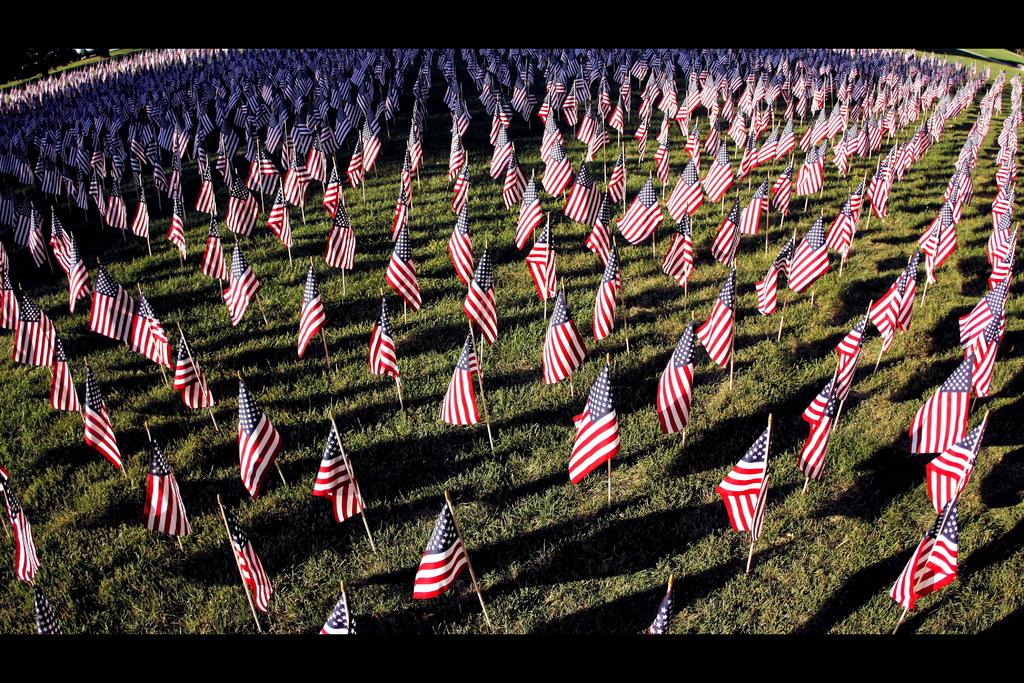What type of flags are visible in the image? There are US flags in the image. Where are the flags located? The flags are on the grass. What color is the grass in the image? The grass is green. What purpose does the stocking serve in the image? There is no stocking present in the image. 